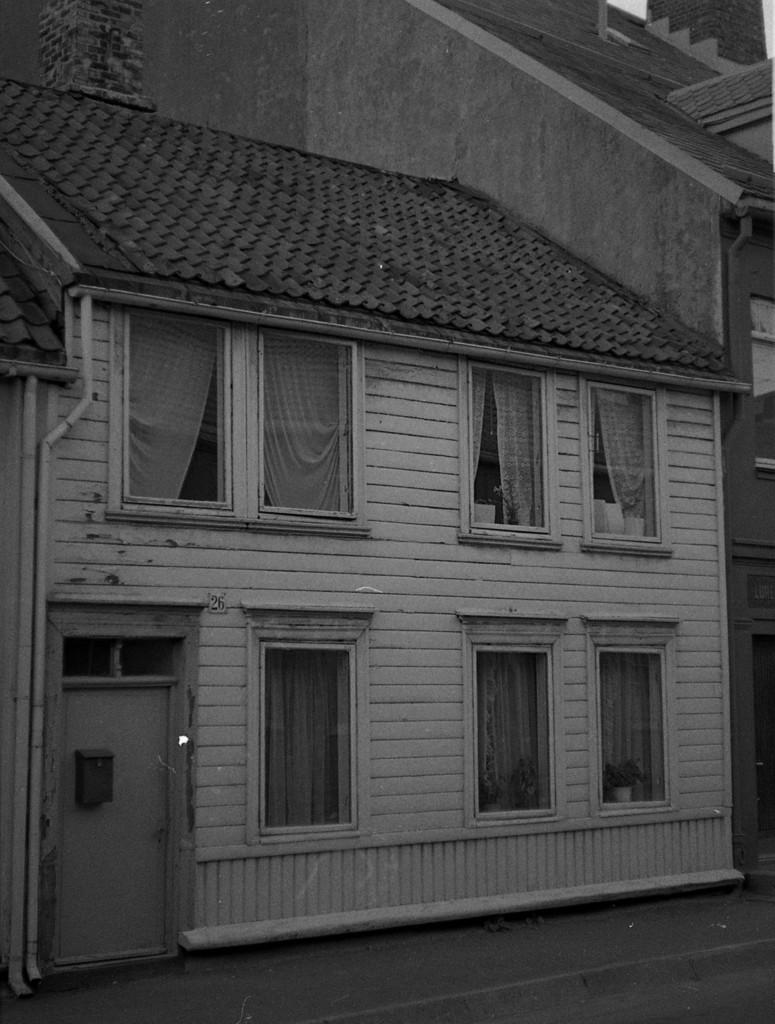What type of structure is present in the image? There is a house in the image. What is the main feature of the house's exterior? The house has a roof. What are some of the house's features that allow light and ventilation? The house has windows. Are there any window treatments visible in the image? Yes, the house has curtains. How can one enter or exit the house? The house has a door. What type of fiction is being read by the house in the image? The house is not reading any fiction in the image, as it is an inanimate object and cannot read. 